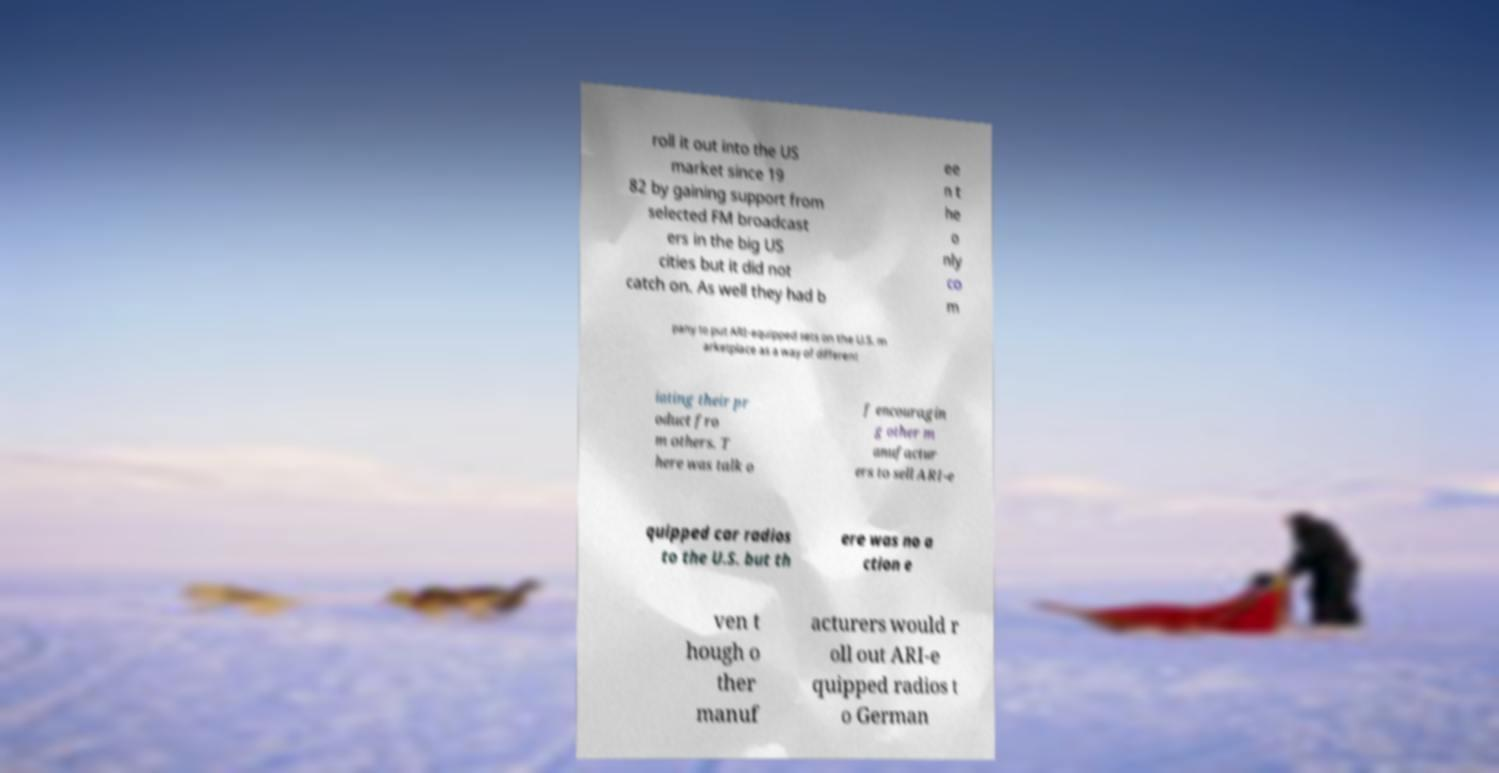Can you read and provide the text displayed in the image?This photo seems to have some interesting text. Can you extract and type it out for me? roll it out into the US market since 19 82 by gaining support from selected FM broadcast ers in the big US cities but it did not catch on. As well they had b ee n t he o nly co m pany to put ARI-equipped sets on the U.S. m arketplace as a way of different iating their pr oduct fro m others. T here was talk o f encouragin g other m anufactur ers to sell ARI-e quipped car radios to the U.S. but th ere was no a ction e ven t hough o ther manuf acturers would r oll out ARI-e quipped radios t o German 